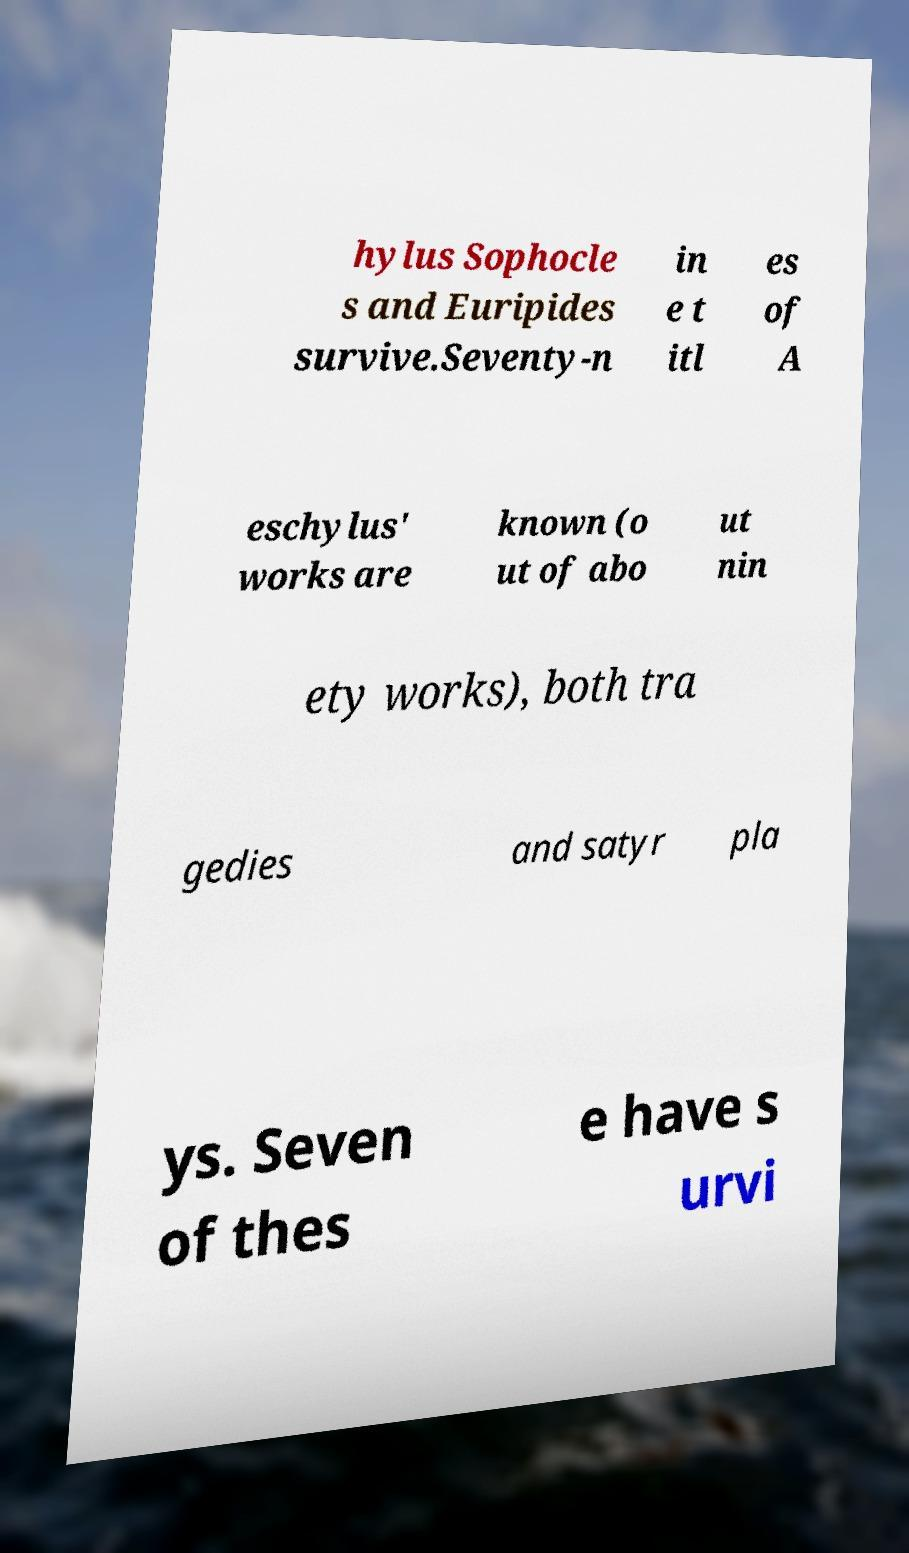Can you read and provide the text displayed in the image?This photo seems to have some interesting text. Can you extract and type it out for me? hylus Sophocle s and Euripides survive.Seventy-n in e t itl es of A eschylus' works are known (o ut of abo ut nin ety works), both tra gedies and satyr pla ys. Seven of thes e have s urvi 